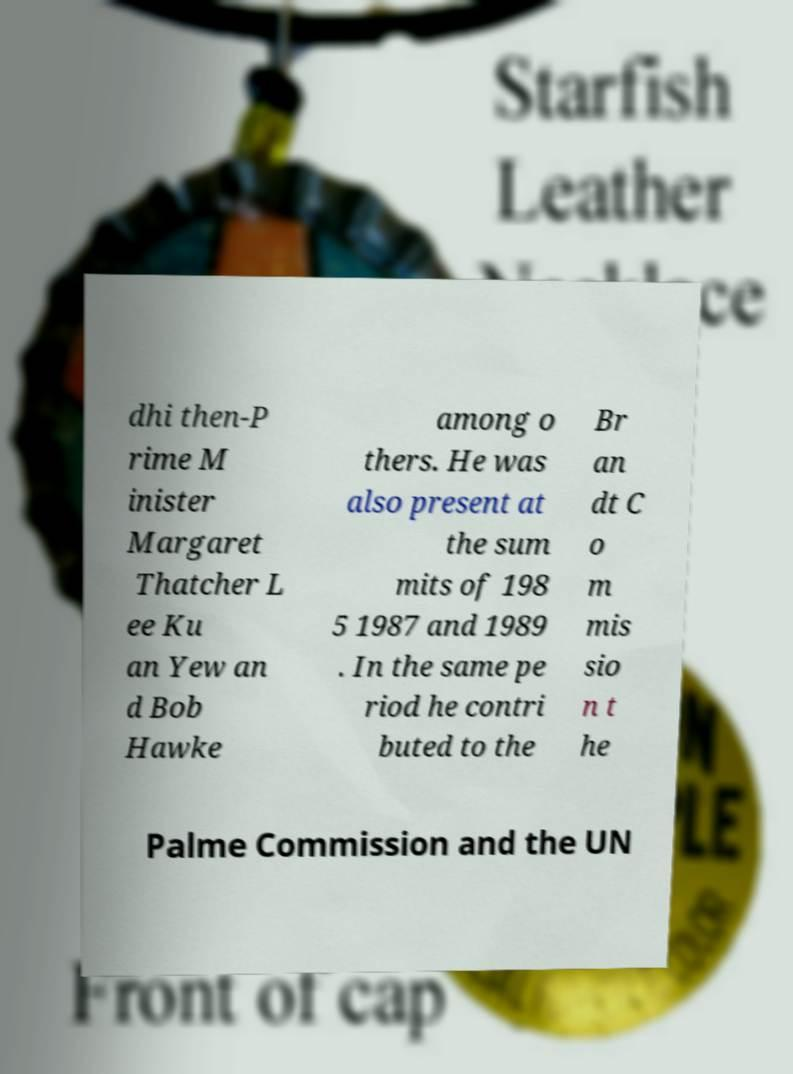Can you accurately transcribe the text from the provided image for me? dhi then-P rime M inister Margaret Thatcher L ee Ku an Yew an d Bob Hawke among o thers. He was also present at the sum mits of 198 5 1987 and 1989 . In the same pe riod he contri buted to the Br an dt C o m mis sio n t he Palme Commission and the UN 